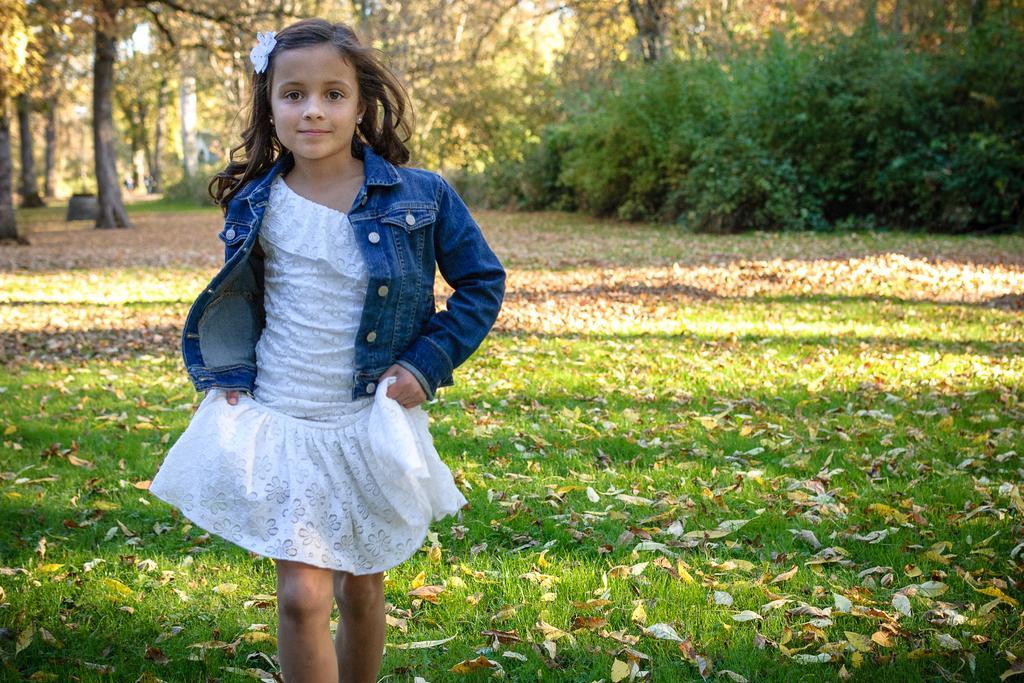Please provide a concise description of this image. In this image we can see a girl walking on the grass, bushes, shredded leaves, trees and sky. 